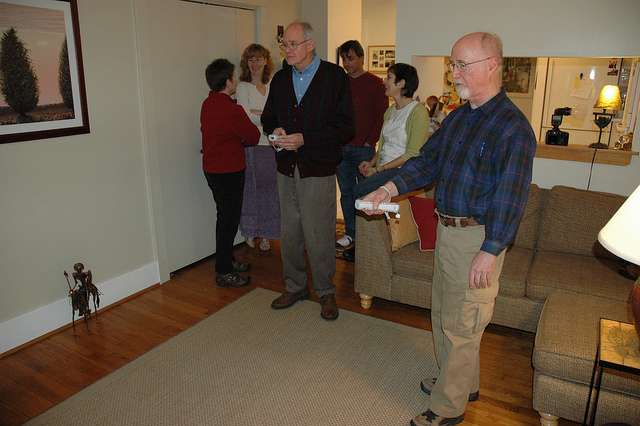<image>What is the man's job? It is unknown what the man's job is. It could range from being a gamer, accountant, writer or even the head of a company. What is the man's job? It is unanswerable what the man's job is. 